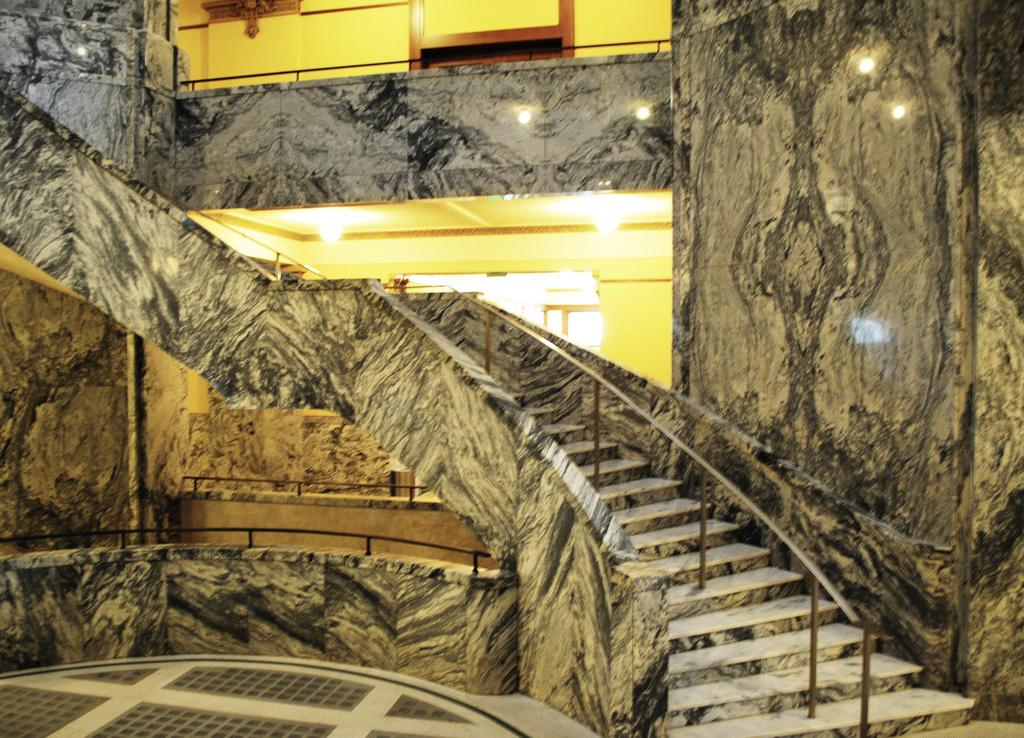What type of structure is present in the image? There is a staircase in the image. What is the surface that the staircase is on? The image shows a floor. What can be seen in the background of the image? There are lights and a wall visible in the background of the image. What type of appliance is making noise in the image? There is no appliance present in the image, and therefore no noise can be heard. 